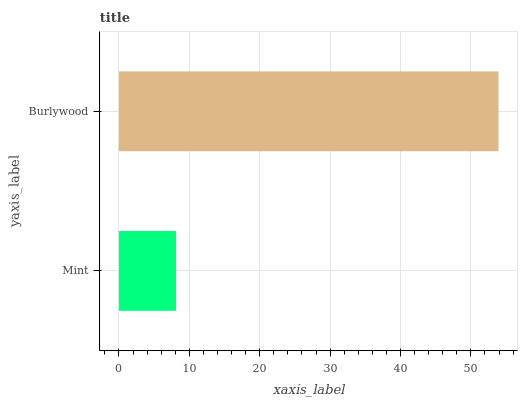Is Mint the minimum?
Answer yes or no. Yes. Is Burlywood the maximum?
Answer yes or no. Yes. Is Burlywood the minimum?
Answer yes or no. No. Is Burlywood greater than Mint?
Answer yes or no. Yes. Is Mint less than Burlywood?
Answer yes or no. Yes. Is Mint greater than Burlywood?
Answer yes or no. No. Is Burlywood less than Mint?
Answer yes or no. No. Is Burlywood the high median?
Answer yes or no. Yes. Is Mint the low median?
Answer yes or no. Yes. Is Mint the high median?
Answer yes or no. No. Is Burlywood the low median?
Answer yes or no. No. 